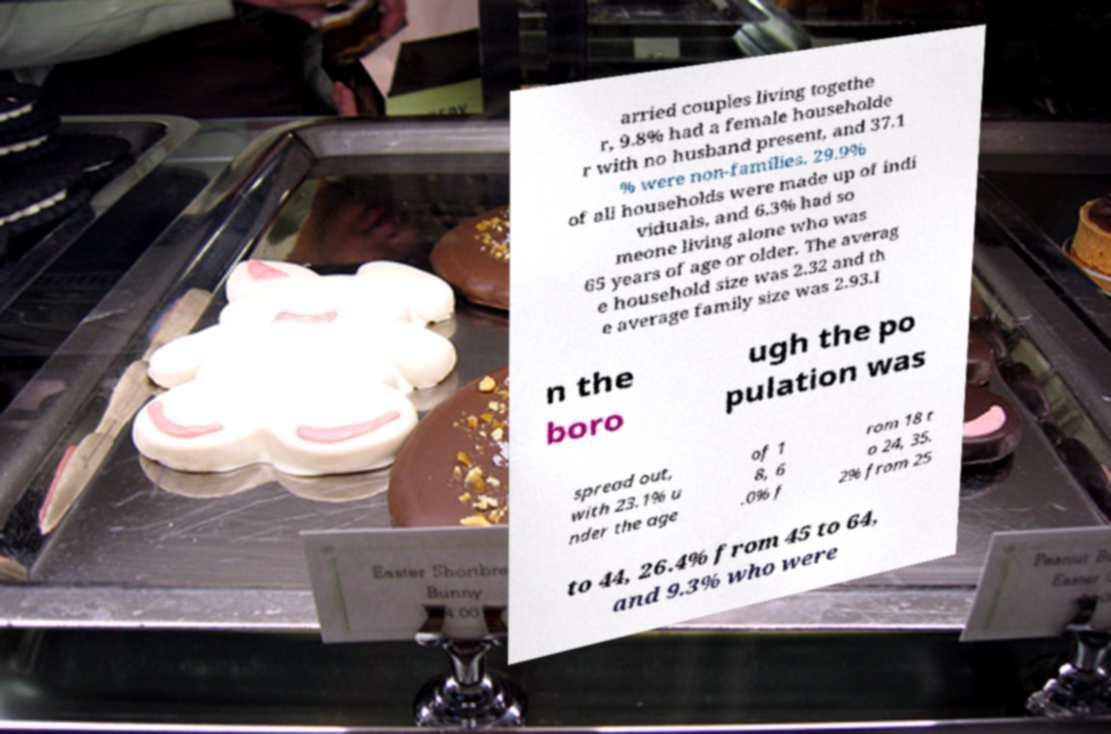I need the written content from this picture converted into text. Can you do that? arried couples living togethe r, 9.8% had a female householde r with no husband present, and 37.1 % were non-families. 29.9% of all households were made up of indi viduals, and 6.3% had so meone living alone who was 65 years of age or older. The averag e household size was 2.32 and th e average family size was 2.93.I n the boro ugh the po pulation was spread out, with 23.1% u nder the age of 1 8, 6 .0% f rom 18 t o 24, 35. 2% from 25 to 44, 26.4% from 45 to 64, and 9.3% who were 